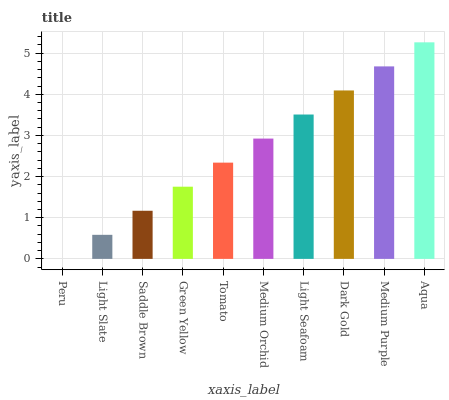Is Peru the minimum?
Answer yes or no. Yes. Is Aqua the maximum?
Answer yes or no. Yes. Is Light Slate the minimum?
Answer yes or no. No. Is Light Slate the maximum?
Answer yes or no. No. Is Light Slate greater than Peru?
Answer yes or no. Yes. Is Peru less than Light Slate?
Answer yes or no. Yes. Is Peru greater than Light Slate?
Answer yes or no. No. Is Light Slate less than Peru?
Answer yes or no. No. Is Medium Orchid the high median?
Answer yes or no. Yes. Is Tomato the low median?
Answer yes or no. Yes. Is Aqua the high median?
Answer yes or no. No. Is Dark Gold the low median?
Answer yes or no. No. 